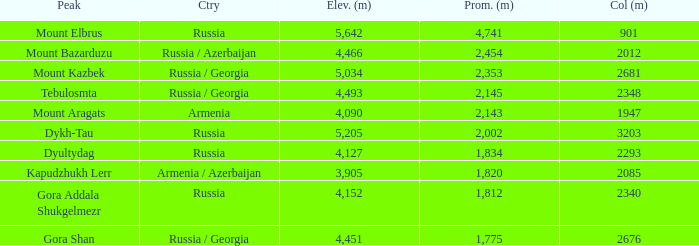With a Col (m) larger than 2012, what is Mount Kazbek's Prominence (m)? 2353.0. 